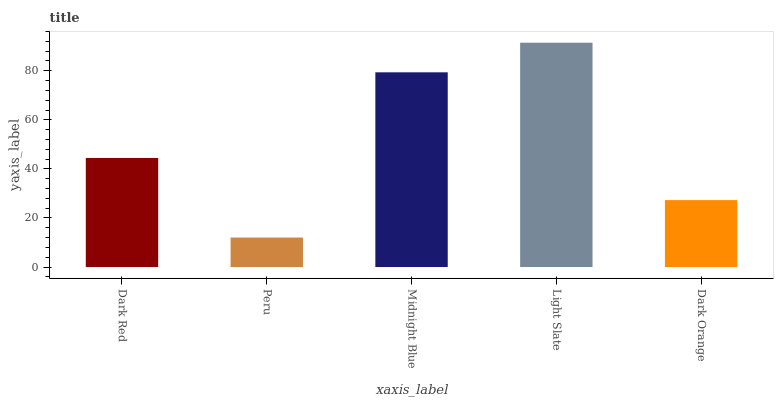Is Peru the minimum?
Answer yes or no. Yes. Is Light Slate the maximum?
Answer yes or no. Yes. Is Midnight Blue the minimum?
Answer yes or no. No. Is Midnight Blue the maximum?
Answer yes or no. No. Is Midnight Blue greater than Peru?
Answer yes or no. Yes. Is Peru less than Midnight Blue?
Answer yes or no. Yes. Is Peru greater than Midnight Blue?
Answer yes or no. No. Is Midnight Blue less than Peru?
Answer yes or no. No. Is Dark Red the high median?
Answer yes or no. Yes. Is Dark Red the low median?
Answer yes or no. Yes. Is Midnight Blue the high median?
Answer yes or no. No. Is Light Slate the low median?
Answer yes or no. No. 